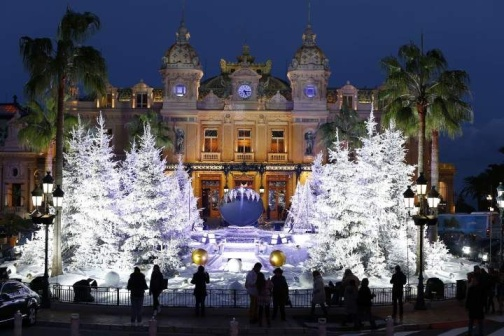What would an alien visitor think upon seeing this scene for the first time? An alien visitor, upon seeing this dazzling scene for the first time, might interpret it as a significant cultural gathering, indicative of the human propensity for beauty and celebration. The grand building would be perceived as a center of authority or community, its radiant lights signifying its importance. The fountain, decorated with glowing ornaments, might be seen as a symbol of wealth or tradition. The palm trees could be understood as a connection to nature within a constructed environment. The presence of people and the festive ambiance would likely intrigue the alien, showcasing the human ability to blend natural and architectural elements into a harmonious celebration of life and togetherness. 